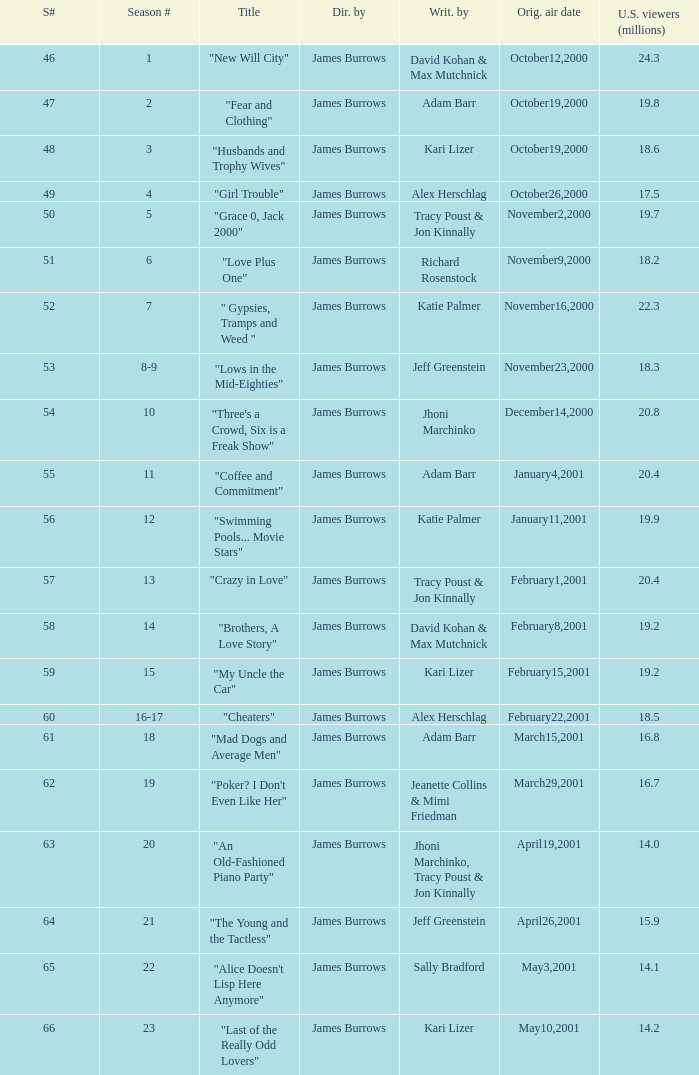Who wrote episode 23 in the season? Kari Lizer. Would you mind parsing the complete table? {'header': ['S#', 'Season #', 'Title', 'Dir. by', 'Writ. by', 'Orig. air date', 'U.S. viewers (millions)'], 'rows': [['46', '1', '"New Will City"', 'James Burrows', 'David Kohan & Max Mutchnick', 'October12,2000', '24.3'], ['47', '2', '"Fear and Clothing"', 'James Burrows', 'Adam Barr', 'October19,2000', '19.8'], ['48', '3', '"Husbands and Trophy Wives"', 'James Burrows', 'Kari Lizer', 'October19,2000', '18.6'], ['49', '4', '"Girl Trouble"', 'James Burrows', 'Alex Herschlag', 'October26,2000', '17.5'], ['50', '5', '"Grace 0, Jack 2000"', 'James Burrows', 'Tracy Poust & Jon Kinnally', 'November2,2000', '19.7'], ['51', '6', '"Love Plus One"', 'James Burrows', 'Richard Rosenstock', 'November9,2000', '18.2'], ['52', '7', '" Gypsies, Tramps and Weed "', 'James Burrows', 'Katie Palmer', 'November16,2000', '22.3'], ['53', '8-9', '"Lows in the Mid-Eighties"', 'James Burrows', 'Jeff Greenstein', 'November23,2000', '18.3'], ['54', '10', '"Three\'s a Crowd, Six is a Freak Show"', 'James Burrows', 'Jhoni Marchinko', 'December14,2000', '20.8'], ['55', '11', '"Coffee and Commitment"', 'James Burrows', 'Adam Barr', 'January4,2001', '20.4'], ['56', '12', '"Swimming Pools... Movie Stars"', 'James Burrows', 'Katie Palmer', 'January11,2001', '19.9'], ['57', '13', '"Crazy in Love"', 'James Burrows', 'Tracy Poust & Jon Kinnally', 'February1,2001', '20.4'], ['58', '14', '"Brothers, A Love Story"', 'James Burrows', 'David Kohan & Max Mutchnick', 'February8,2001', '19.2'], ['59', '15', '"My Uncle the Car"', 'James Burrows', 'Kari Lizer', 'February15,2001', '19.2'], ['60', '16-17', '"Cheaters"', 'James Burrows', 'Alex Herschlag', 'February22,2001', '18.5'], ['61', '18', '"Mad Dogs and Average Men"', 'James Burrows', 'Adam Barr', 'March15,2001', '16.8'], ['62', '19', '"Poker? I Don\'t Even Like Her"', 'James Burrows', 'Jeanette Collins & Mimi Friedman', 'March29,2001', '16.7'], ['63', '20', '"An Old-Fashioned Piano Party"', 'James Burrows', 'Jhoni Marchinko, Tracy Poust & Jon Kinnally', 'April19,2001', '14.0'], ['64', '21', '"The Young and the Tactless"', 'James Burrows', 'Jeff Greenstein', 'April26,2001', '15.9'], ['65', '22', '"Alice Doesn\'t Lisp Here Anymore"', 'James Burrows', 'Sally Bradford', 'May3,2001', '14.1'], ['66', '23', '"Last of the Really Odd Lovers"', 'James Burrows', 'Kari Lizer', 'May10,2001', '14.2']]} 